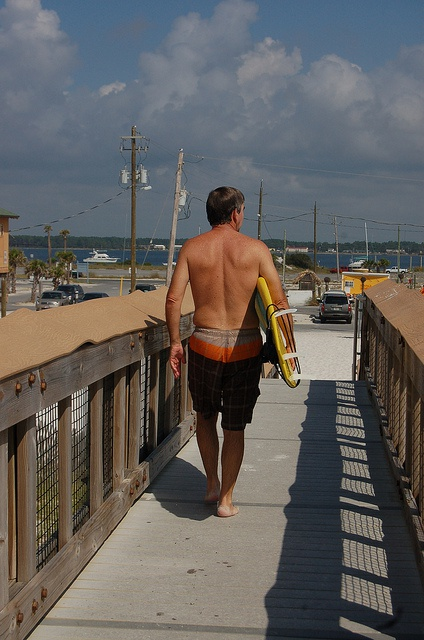Describe the objects in this image and their specific colors. I can see people in gray, black, brown, salmon, and maroon tones, surfboard in gray, black, olive, and maroon tones, car in gray, black, maroon, and darkgray tones, car in gray, black, and darkgray tones, and boat in gray, darkgray, black, and lightgray tones in this image. 